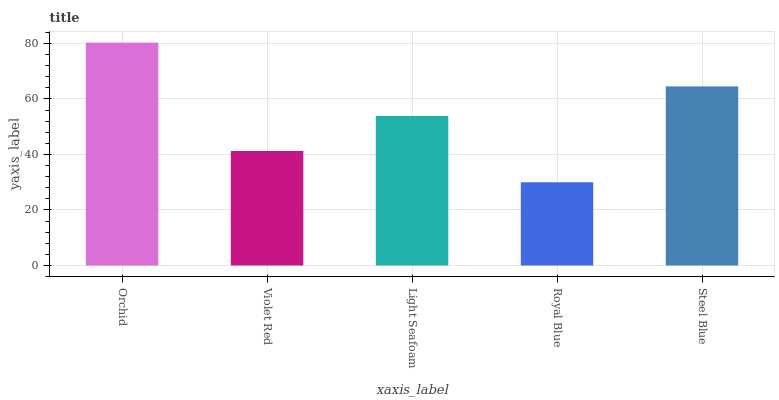Is Royal Blue the minimum?
Answer yes or no. Yes. Is Orchid the maximum?
Answer yes or no. Yes. Is Violet Red the minimum?
Answer yes or no. No. Is Violet Red the maximum?
Answer yes or no. No. Is Orchid greater than Violet Red?
Answer yes or no. Yes. Is Violet Red less than Orchid?
Answer yes or no. Yes. Is Violet Red greater than Orchid?
Answer yes or no. No. Is Orchid less than Violet Red?
Answer yes or no. No. Is Light Seafoam the high median?
Answer yes or no. Yes. Is Light Seafoam the low median?
Answer yes or no. Yes. Is Orchid the high median?
Answer yes or no. No. Is Steel Blue the low median?
Answer yes or no. No. 